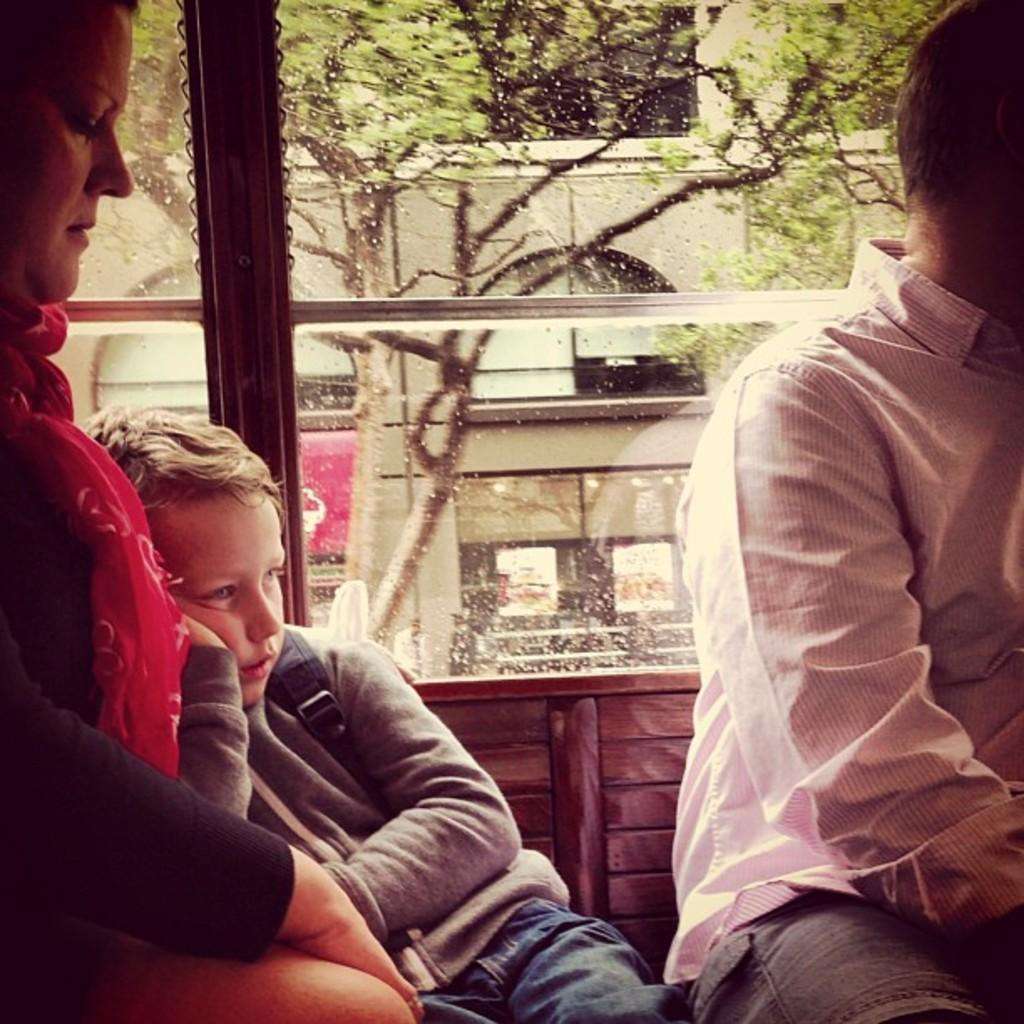How many people are present in the image? There are three people in the image. What can be seen in the background of the image? There is a building, trees, posters, and people in the background of the image. How many girls are sitting on the beam in the image? There is no beam or girls present in the image. 